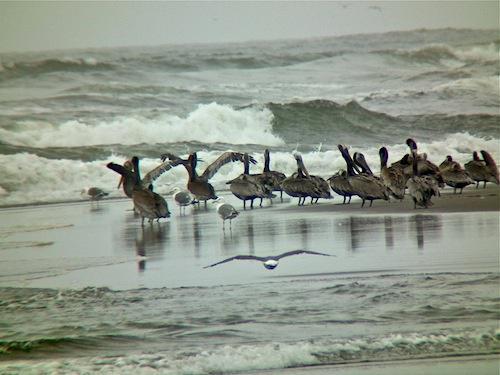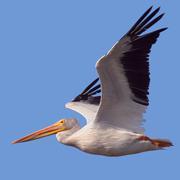The first image is the image on the left, the second image is the image on the right. Given the left and right images, does the statement "there is a single pelican in flight" hold true? Answer yes or no. Yes. The first image is the image on the left, the second image is the image on the right. For the images displayed, is the sentence "The right image contains at least four birds." factually correct? Answer yes or no. No. 